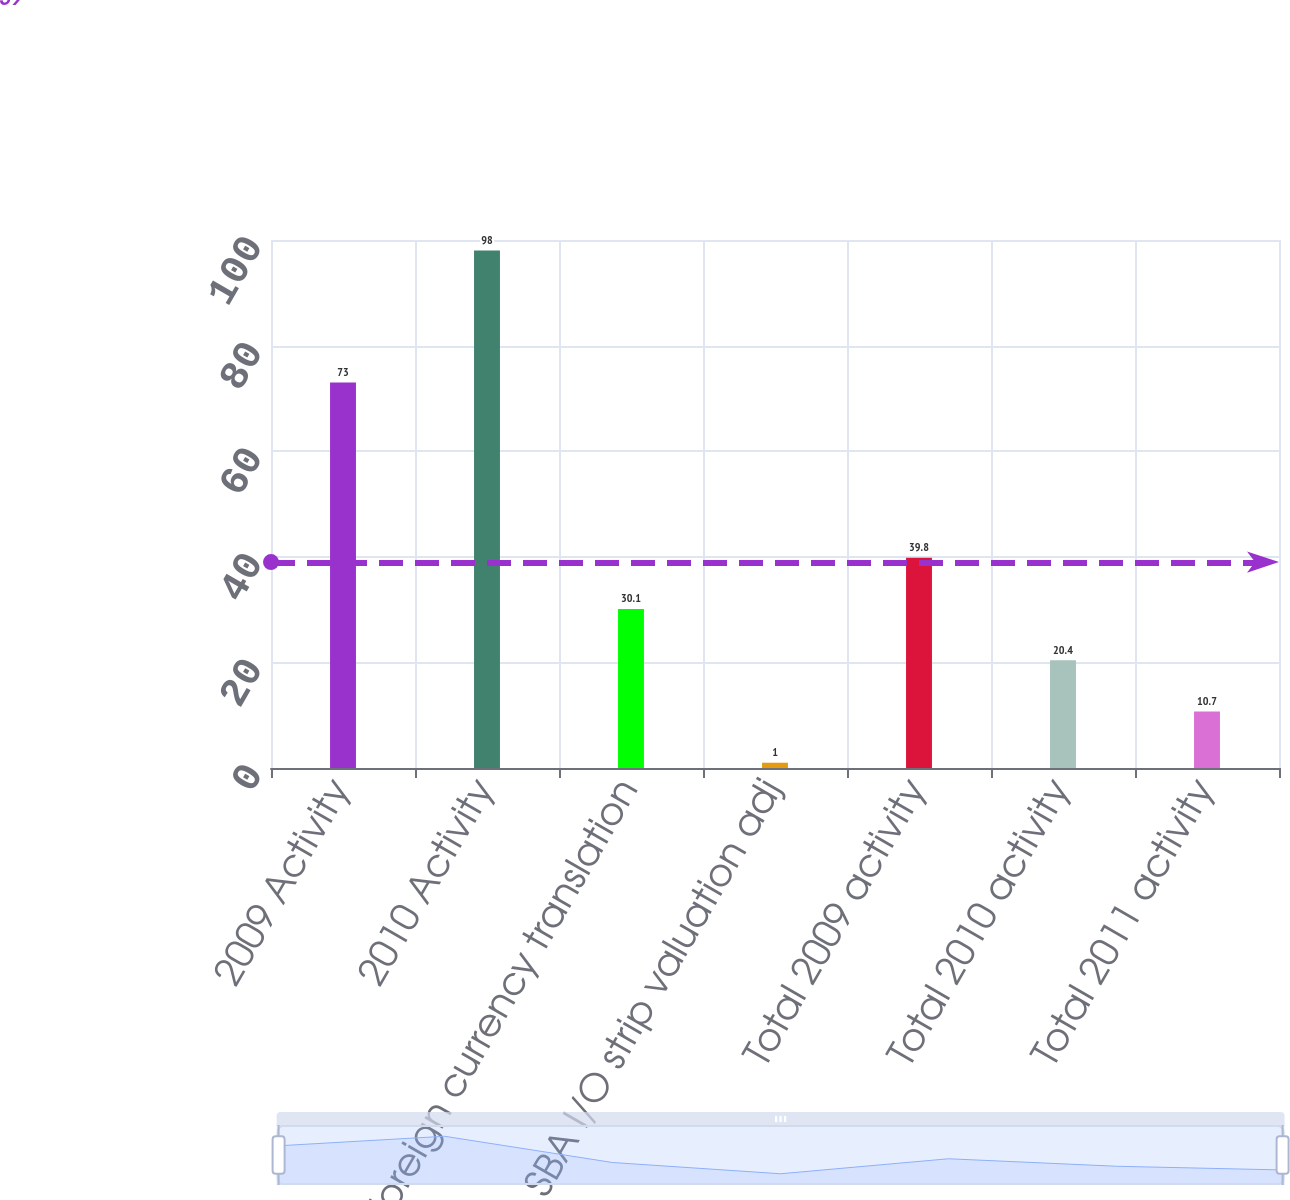Convert chart to OTSL. <chart><loc_0><loc_0><loc_500><loc_500><bar_chart><fcel>2009 Activity<fcel>2010 Activity<fcel>Foreign currency translation<fcel>SBA I/O strip valuation adj<fcel>Total 2009 activity<fcel>Total 2010 activity<fcel>Total 2011 activity<nl><fcel>73<fcel>98<fcel>30.1<fcel>1<fcel>39.8<fcel>20.4<fcel>10.7<nl></chart> 